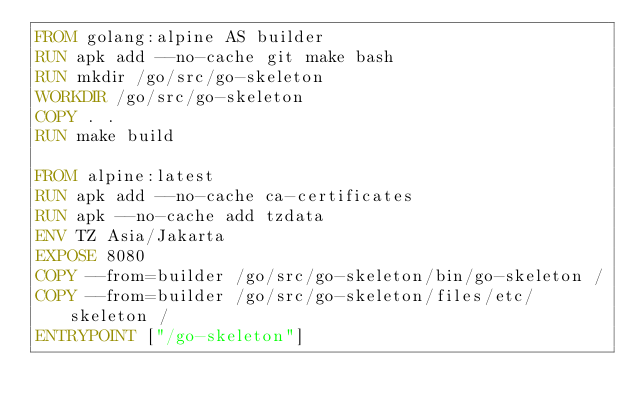<code> <loc_0><loc_0><loc_500><loc_500><_Dockerfile_>FROM golang:alpine AS builder
RUN apk add --no-cache git make bash
RUN mkdir /go/src/go-skeleton
WORKDIR /go/src/go-skeleton
COPY . .
RUN make build

FROM alpine:latest
RUN apk add --no-cache ca-certificates
RUN apk --no-cache add tzdata
ENV TZ Asia/Jakarta
EXPOSE 8080
COPY --from=builder /go/src/go-skeleton/bin/go-skeleton /
COPY --from=builder /go/src/go-skeleton/files/etc/skeleton /
ENTRYPOINT ["/go-skeleton"]
</code> 